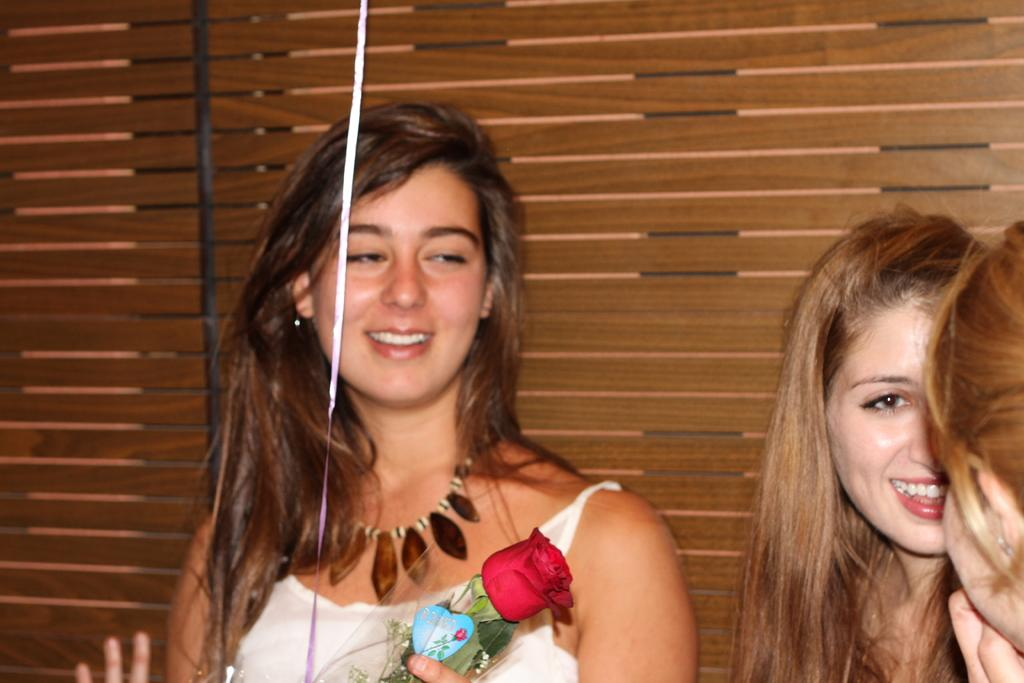How many women are in the image? There are three women in the image. What is one of the women holding? One woman is holding a rose. How does the woman holding the rose appear to feel? The woman holding the rose is smiling. What can be seen in the background of the image? There is a wooden wall in the background of the image. What grade did the women receive for their performance in the image? There is no indication of a performance or grade in the image; it simply shows three women, one of whom is holding a rose and smiling. 